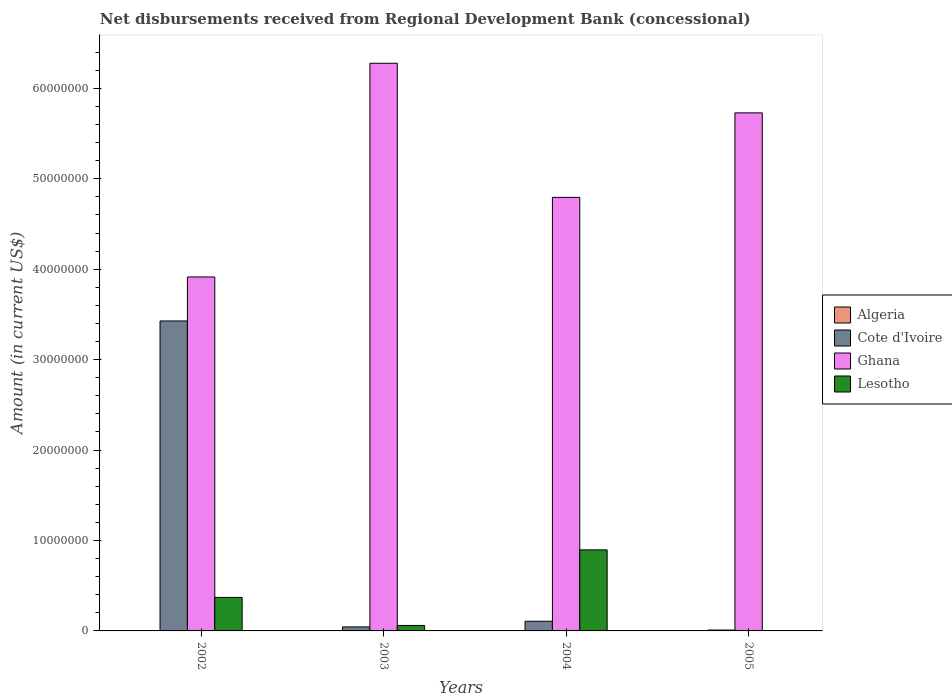How many different coloured bars are there?
Offer a very short reply. 3. Are the number of bars per tick equal to the number of legend labels?
Keep it short and to the point. No. How many bars are there on the 3rd tick from the left?
Provide a succinct answer. 3. How many bars are there on the 2nd tick from the right?
Offer a very short reply. 3. What is the label of the 2nd group of bars from the left?
Keep it short and to the point. 2003. What is the amount of disbursements received from Regional Development Bank in Ghana in 2004?
Your answer should be compact. 4.79e+07. Across all years, what is the maximum amount of disbursements received from Regional Development Bank in Ghana?
Ensure brevity in your answer.  6.28e+07. What is the total amount of disbursements received from Regional Development Bank in Ghana in the graph?
Your answer should be compact. 2.07e+08. What is the difference between the amount of disbursements received from Regional Development Bank in Cote d'Ivoire in 2004 and that in 2005?
Provide a succinct answer. 9.75e+05. What is the difference between the amount of disbursements received from Regional Development Bank in Lesotho in 2005 and the amount of disbursements received from Regional Development Bank in Ghana in 2004?
Give a very brief answer. -4.79e+07. What is the average amount of disbursements received from Regional Development Bank in Algeria per year?
Your answer should be compact. 0. In the year 2002, what is the difference between the amount of disbursements received from Regional Development Bank in Lesotho and amount of disbursements received from Regional Development Bank in Ghana?
Give a very brief answer. -3.54e+07. What is the ratio of the amount of disbursements received from Regional Development Bank in Cote d'Ivoire in 2004 to that in 2005?
Offer a terse response. 11.26. What is the difference between the highest and the second highest amount of disbursements received from Regional Development Bank in Ghana?
Make the answer very short. 5.49e+06. What is the difference between the highest and the lowest amount of disbursements received from Regional Development Bank in Cote d'Ivoire?
Ensure brevity in your answer.  3.42e+07. In how many years, is the amount of disbursements received from Regional Development Bank in Ghana greater than the average amount of disbursements received from Regional Development Bank in Ghana taken over all years?
Your answer should be compact. 2. Is it the case that in every year, the sum of the amount of disbursements received from Regional Development Bank in Cote d'Ivoire and amount of disbursements received from Regional Development Bank in Lesotho is greater than the sum of amount of disbursements received from Regional Development Bank in Algeria and amount of disbursements received from Regional Development Bank in Ghana?
Your response must be concise. No. Is it the case that in every year, the sum of the amount of disbursements received from Regional Development Bank in Algeria and amount of disbursements received from Regional Development Bank in Cote d'Ivoire is greater than the amount of disbursements received from Regional Development Bank in Ghana?
Offer a very short reply. No. How many years are there in the graph?
Keep it short and to the point. 4. What is the difference between two consecutive major ticks on the Y-axis?
Your answer should be very brief. 1.00e+07. Does the graph contain grids?
Ensure brevity in your answer.  No. How are the legend labels stacked?
Provide a succinct answer. Vertical. What is the title of the graph?
Offer a terse response. Net disbursements received from Regional Development Bank (concessional). What is the label or title of the Y-axis?
Your response must be concise. Amount (in current US$). What is the Amount (in current US$) in Algeria in 2002?
Keep it short and to the point. 0. What is the Amount (in current US$) in Cote d'Ivoire in 2002?
Offer a terse response. 3.43e+07. What is the Amount (in current US$) in Ghana in 2002?
Offer a terse response. 3.91e+07. What is the Amount (in current US$) of Lesotho in 2002?
Provide a succinct answer. 3.70e+06. What is the Amount (in current US$) of Algeria in 2003?
Provide a succinct answer. 0. What is the Amount (in current US$) of Cote d'Ivoire in 2003?
Your response must be concise. 4.43e+05. What is the Amount (in current US$) of Ghana in 2003?
Make the answer very short. 6.28e+07. What is the Amount (in current US$) in Lesotho in 2003?
Your answer should be very brief. 6.05e+05. What is the Amount (in current US$) in Algeria in 2004?
Your answer should be compact. 0. What is the Amount (in current US$) of Cote d'Ivoire in 2004?
Provide a short and direct response. 1.07e+06. What is the Amount (in current US$) of Ghana in 2004?
Provide a succinct answer. 4.79e+07. What is the Amount (in current US$) of Lesotho in 2004?
Offer a terse response. 8.96e+06. What is the Amount (in current US$) in Cote d'Ivoire in 2005?
Keep it short and to the point. 9.50e+04. What is the Amount (in current US$) of Ghana in 2005?
Provide a succinct answer. 5.73e+07. Across all years, what is the maximum Amount (in current US$) of Cote d'Ivoire?
Ensure brevity in your answer.  3.43e+07. Across all years, what is the maximum Amount (in current US$) of Ghana?
Your answer should be very brief. 6.28e+07. Across all years, what is the maximum Amount (in current US$) of Lesotho?
Give a very brief answer. 8.96e+06. Across all years, what is the minimum Amount (in current US$) in Cote d'Ivoire?
Your answer should be compact. 9.50e+04. Across all years, what is the minimum Amount (in current US$) of Ghana?
Ensure brevity in your answer.  3.91e+07. Across all years, what is the minimum Amount (in current US$) of Lesotho?
Your response must be concise. 0. What is the total Amount (in current US$) in Algeria in the graph?
Your response must be concise. 0. What is the total Amount (in current US$) in Cote d'Ivoire in the graph?
Provide a short and direct response. 3.59e+07. What is the total Amount (in current US$) of Ghana in the graph?
Give a very brief answer. 2.07e+08. What is the total Amount (in current US$) in Lesotho in the graph?
Offer a very short reply. 1.33e+07. What is the difference between the Amount (in current US$) in Cote d'Ivoire in 2002 and that in 2003?
Your answer should be very brief. 3.38e+07. What is the difference between the Amount (in current US$) of Ghana in 2002 and that in 2003?
Provide a short and direct response. -2.36e+07. What is the difference between the Amount (in current US$) of Lesotho in 2002 and that in 2003?
Your answer should be very brief. 3.10e+06. What is the difference between the Amount (in current US$) of Cote d'Ivoire in 2002 and that in 2004?
Keep it short and to the point. 3.32e+07. What is the difference between the Amount (in current US$) in Ghana in 2002 and that in 2004?
Offer a very short reply. -8.80e+06. What is the difference between the Amount (in current US$) in Lesotho in 2002 and that in 2004?
Ensure brevity in your answer.  -5.26e+06. What is the difference between the Amount (in current US$) in Cote d'Ivoire in 2002 and that in 2005?
Your response must be concise. 3.42e+07. What is the difference between the Amount (in current US$) of Ghana in 2002 and that in 2005?
Provide a short and direct response. -1.81e+07. What is the difference between the Amount (in current US$) of Cote d'Ivoire in 2003 and that in 2004?
Your answer should be compact. -6.27e+05. What is the difference between the Amount (in current US$) of Ghana in 2003 and that in 2004?
Make the answer very short. 1.48e+07. What is the difference between the Amount (in current US$) of Lesotho in 2003 and that in 2004?
Give a very brief answer. -8.36e+06. What is the difference between the Amount (in current US$) in Cote d'Ivoire in 2003 and that in 2005?
Provide a short and direct response. 3.48e+05. What is the difference between the Amount (in current US$) of Ghana in 2003 and that in 2005?
Your response must be concise. 5.49e+06. What is the difference between the Amount (in current US$) in Cote d'Ivoire in 2004 and that in 2005?
Give a very brief answer. 9.75e+05. What is the difference between the Amount (in current US$) of Ghana in 2004 and that in 2005?
Give a very brief answer. -9.34e+06. What is the difference between the Amount (in current US$) of Cote d'Ivoire in 2002 and the Amount (in current US$) of Ghana in 2003?
Your answer should be compact. -2.85e+07. What is the difference between the Amount (in current US$) of Cote d'Ivoire in 2002 and the Amount (in current US$) of Lesotho in 2003?
Your response must be concise. 3.37e+07. What is the difference between the Amount (in current US$) of Ghana in 2002 and the Amount (in current US$) of Lesotho in 2003?
Ensure brevity in your answer.  3.85e+07. What is the difference between the Amount (in current US$) of Cote d'Ivoire in 2002 and the Amount (in current US$) of Ghana in 2004?
Your answer should be very brief. -1.37e+07. What is the difference between the Amount (in current US$) in Cote d'Ivoire in 2002 and the Amount (in current US$) in Lesotho in 2004?
Offer a very short reply. 2.53e+07. What is the difference between the Amount (in current US$) of Ghana in 2002 and the Amount (in current US$) of Lesotho in 2004?
Offer a very short reply. 3.02e+07. What is the difference between the Amount (in current US$) in Cote d'Ivoire in 2002 and the Amount (in current US$) in Ghana in 2005?
Your response must be concise. -2.30e+07. What is the difference between the Amount (in current US$) of Cote d'Ivoire in 2003 and the Amount (in current US$) of Ghana in 2004?
Keep it short and to the point. -4.75e+07. What is the difference between the Amount (in current US$) of Cote d'Ivoire in 2003 and the Amount (in current US$) of Lesotho in 2004?
Your answer should be compact. -8.52e+06. What is the difference between the Amount (in current US$) in Ghana in 2003 and the Amount (in current US$) in Lesotho in 2004?
Ensure brevity in your answer.  5.38e+07. What is the difference between the Amount (in current US$) in Cote d'Ivoire in 2003 and the Amount (in current US$) in Ghana in 2005?
Provide a short and direct response. -5.68e+07. What is the difference between the Amount (in current US$) of Cote d'Ivoire in 2004 and the Amount (in current US$) of Ghana in 2005?
Provide a short and direct response. -5.62e+07. What is the average Amount (in current US$) in Cote d'Ivoire per year?
Offer a terse response. 8.97e+06. What is the average Amount (in current US$) of Ghana per year?
Keep it short and to the point. 5.18e+07. What is the average Amount (in current US$) in Lesotho per year?
Your answer should be very brief. 3.32e+06. In the year 2002, what is the difference between the Amount (in current US$) of Cote d'Ivoire and Amount (in current US$) of Ghana?
Ensure brevity in your answer.  -4.86e+06. In the year 2002, what is the difference between the Amount (in current US$) of Cote d'Ivoire and Amount (in current US$) of Lesotho?
Your answer should be compact. 3.06e+07. In the year 2002, what is the difference between the Amount (in current US$) of Ghana and Amount (in current US$) of Lesotho?
Your response must be concise. 3.54e+07. In the year 2003, what is the difference between the Amount (in current US$) in Cote d'Ivoire and Amount (in current US$) in Ghana?
Provide a succinct answer. -6.23e+07. In the year 2003, what is the difference between the Amount (in current US$) of Cote d'Ivoire and Amount (in current US$) of Lesotho?
Keep it short and to the point. -1.62e+05. In the year 2003, what is the difference between the Amount (in current US$) in Ghana and Amount (in current US$) in Lesotho?
Make the answer very short. 6.22e+07. In the year 2004, what is the difference between the Amount (in current US$) in Cote d'Ivoire and Amount (in current US$) in Ghana?
Provide a succinct answer. -4.69e+07. In the year 2004, what is the difference between the Amount (in current US$) of Cote d'Ivoire and Amount (in current US$) of Lesotho?
Offer a terse response. -7.89e+06. In the year 2004, what is the difference between the Amount (in current US$) of Ghana and Amount (in current US$) of Lesotho?
Ensure brevity in your answer.  3.90e+07. In the year 2005, what is the difference between the Amount (in current US$) of Cote d'Ivoire and Amount (in current US$) of Ghana?
Offer a terse response. -5.72e+07. What is the ratio of the Amount (in current US$) of Cote d'Ivoire in 2002 to that in 2003?
Provide a short and direct response. 77.38. What is the ratio of the Amount (in current US$) in Ghana in 2002 to that in 2003?
Offer a very short reply. 0.62. What is the ratio of the Amount (in current US$) of Lesotho in 2002 to that in 2003?
Offer a very short reply. 6.12. What is the ratio of the Amount (in current US$) of Cote d'Ivoire in 2002 to that in 2004?
Your answer should be very brief. 32.04. What is the ratio of the Amount (in current US$) of Ghana in 2002 to that in 2004?
Ensure brevity in your answer.  0.82. What is the ratio of the Amount (in current US$) in Lesotho in 2002 to that in 2004?
Offer a very short reply. 0.41. What is the ratio of the Amount (in current US$) in Cote d'Ivoire in 2002 to that in 2005?
Provide a short and direct response. 360.82. What is the ratio of the Amount (in current US$) in Ghana in 2002 to that in 2005?
Your answer should be compact. 0.68. What is the ratio of the Amount (in current US$) in Cote d'Ivoire in 2003 to that in 2004?
Provide a short and direct response. 0.41. What is the ratio of the Amount (in current US$) of Ghana in 2003 to that in 2004?
Provide a short and direct response. 1.31. What is the ratio of the Amount (in current US$) in Lesotho in 2003 to that in 2004?
Provide a short and direct response. 0.07. What is the ratio of the Amount (in current US$) in Cote d'Ivoire in 2003 to that in 2005?
Make the answer very short. 4.66. What is the ratio of the Amount (in current US$) of Ghana in 2003 to that in 2005?
Keep it short and to the point. 1.1. What is the ratio of the Amount (in current US$) in Cote d'Ivoire in 2004 to that in 2005?
Offer a terse response. 11.26. What is the ratio of the Amount (in current US$) of Ghana in 2004 to that in 2005?
Ensure brevity in your answer.  0.84. What is the difference between the highest and the second highest Amount (in current US$) in Cote d'Ivoire?
Ensure brevity in your answer.  3.32e+07. What is the difference between the highest and the second highest Amount (in current US$) of Ghana?
Give a very brief answer. 5.49e+06. What is the difference between the highest and the second highest Amount (in current US$) of Lesotho?
Offer a terse response. 5.26e+06. What is the difference between the highest and the lowest Amount (in current US$) of Cote d'Ivoire?
Your response must be concise. 3.42e+07. What is the difference between the highest and the lowest Amount (in current US$) in Ghana?
Ensure brevity in your answer.  2.36e+07. What is the difference between the highest and the lowest Amount (in current US$) in Lesotho?
Provide a succinct answer. 8.96e+06. 